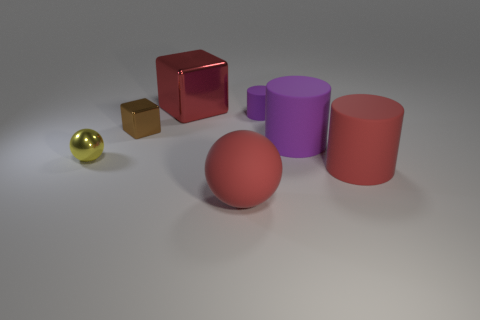Do the large rubber ball and the big block have the same color?
Keep it short and to the point. Yes. There is a red object that is behind the purple rubber cylinder that is behind the big rubber cylinder to the left of the large red rubber cylinder; how big is it?
Offer a very short reply. Large. What is the size of the red thing that is both in front of the large purple rubber cylinder and on the left side of the small purple matte cylinder?
Your answer should be compact. Large. The large red matte object behind the red thing in front of the big red cylinder is what shape?
Provide a short and direct response. Cylinder. Are there any other things of the same color as the tiny metal ball?
Offer a very short reply. No. There is a tiny object on the right side of the red cube; what is its shape?
Ensure brevity in your answer.  Cylinder. There is a thing that is both to the left of the rubber sphere and on the right side of the tiny brown thing; what is its shape?
Your answer should be compact. Cube. What number of red things are shiny objects or matte objects?
Provide a short and direct response. 3. There is a cylinder in front of the tiny yellow metallic thing; does it have the same color as the big matte sphere?
Provide a succinct answer. Yes. There is a red thing that is on the left side of the sphere right of the large red block; what size is it?
Ensure brevity in your answer.  Large. 